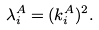<formula> <loc_0><loc_0><loc_500><loc_500>\lambda _ { i } ^ { A } = ( k _ { i } ^ { A } ) ^ { 2 } .</formula> 